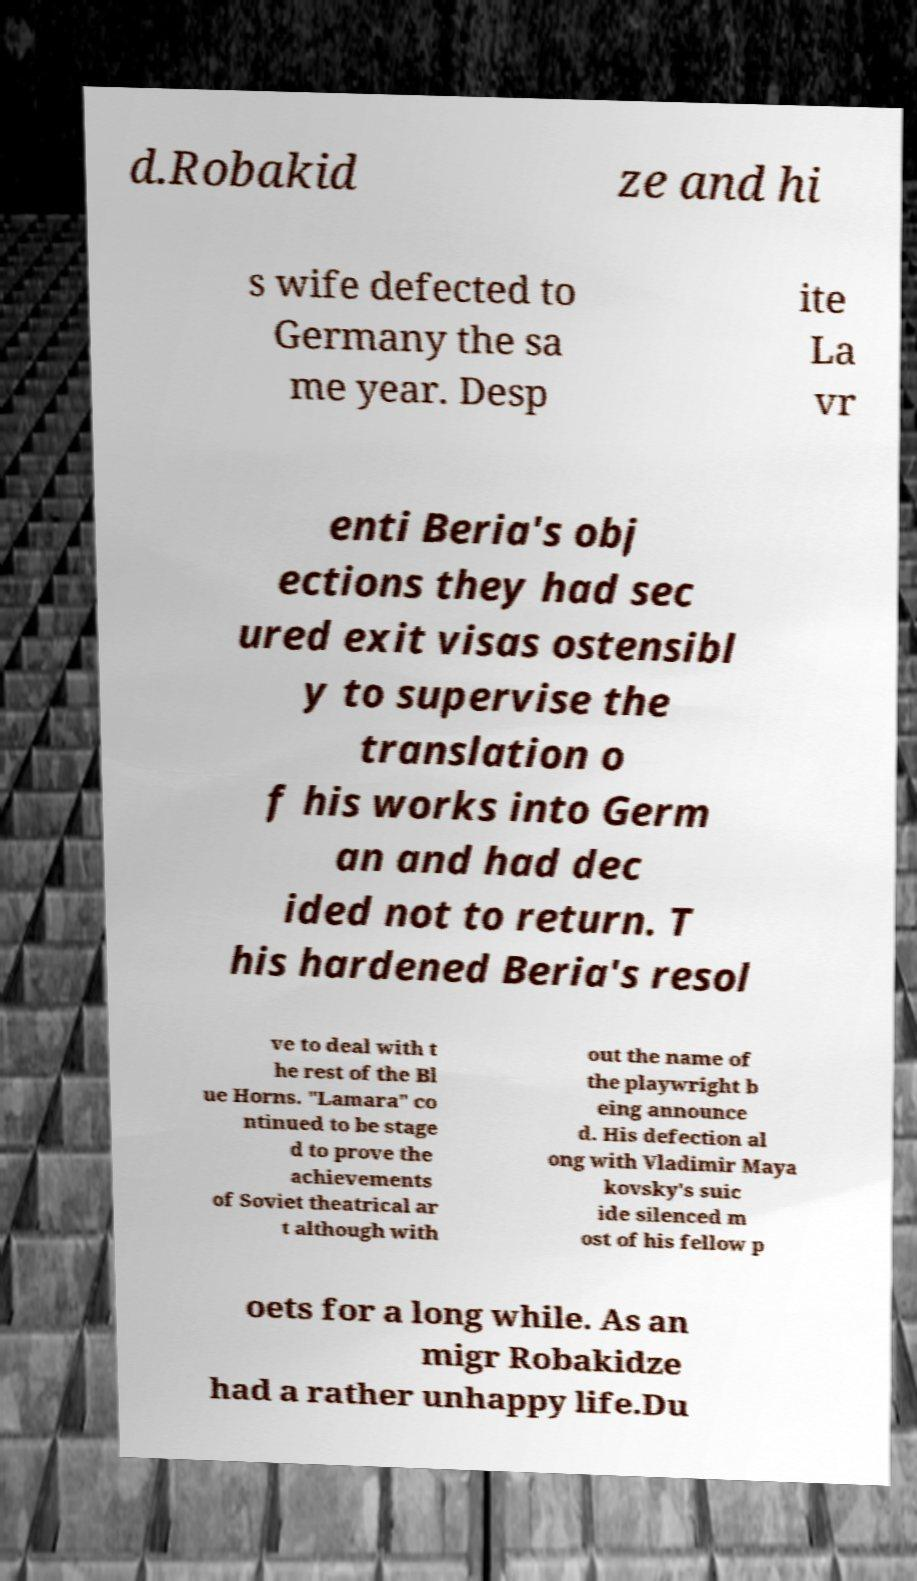Can you accurately transcribe the text from the provided image for me? d.Robakid ze and hi s wife defected to Germany the sa me year. Desp ite La vr enti Beria's obj ections they had sec ured exit visas ostensibl y to supervise the translation o f his works into Germ an and had dec ided not to return. T his hardened Beria's resol ve to deal with t he rest of the Bl ue Horns. "Lamara" co ntinued to be stage d to prove the achievements of Soviet theatrical ar t although with out the name of the playwright b eing announce d. His defection al ong with Vladimir Maya kovsky's suic ide silenced m ost of his fellow p oets for a long while. As an migr Robakidze had a rather unhappy life.Du 